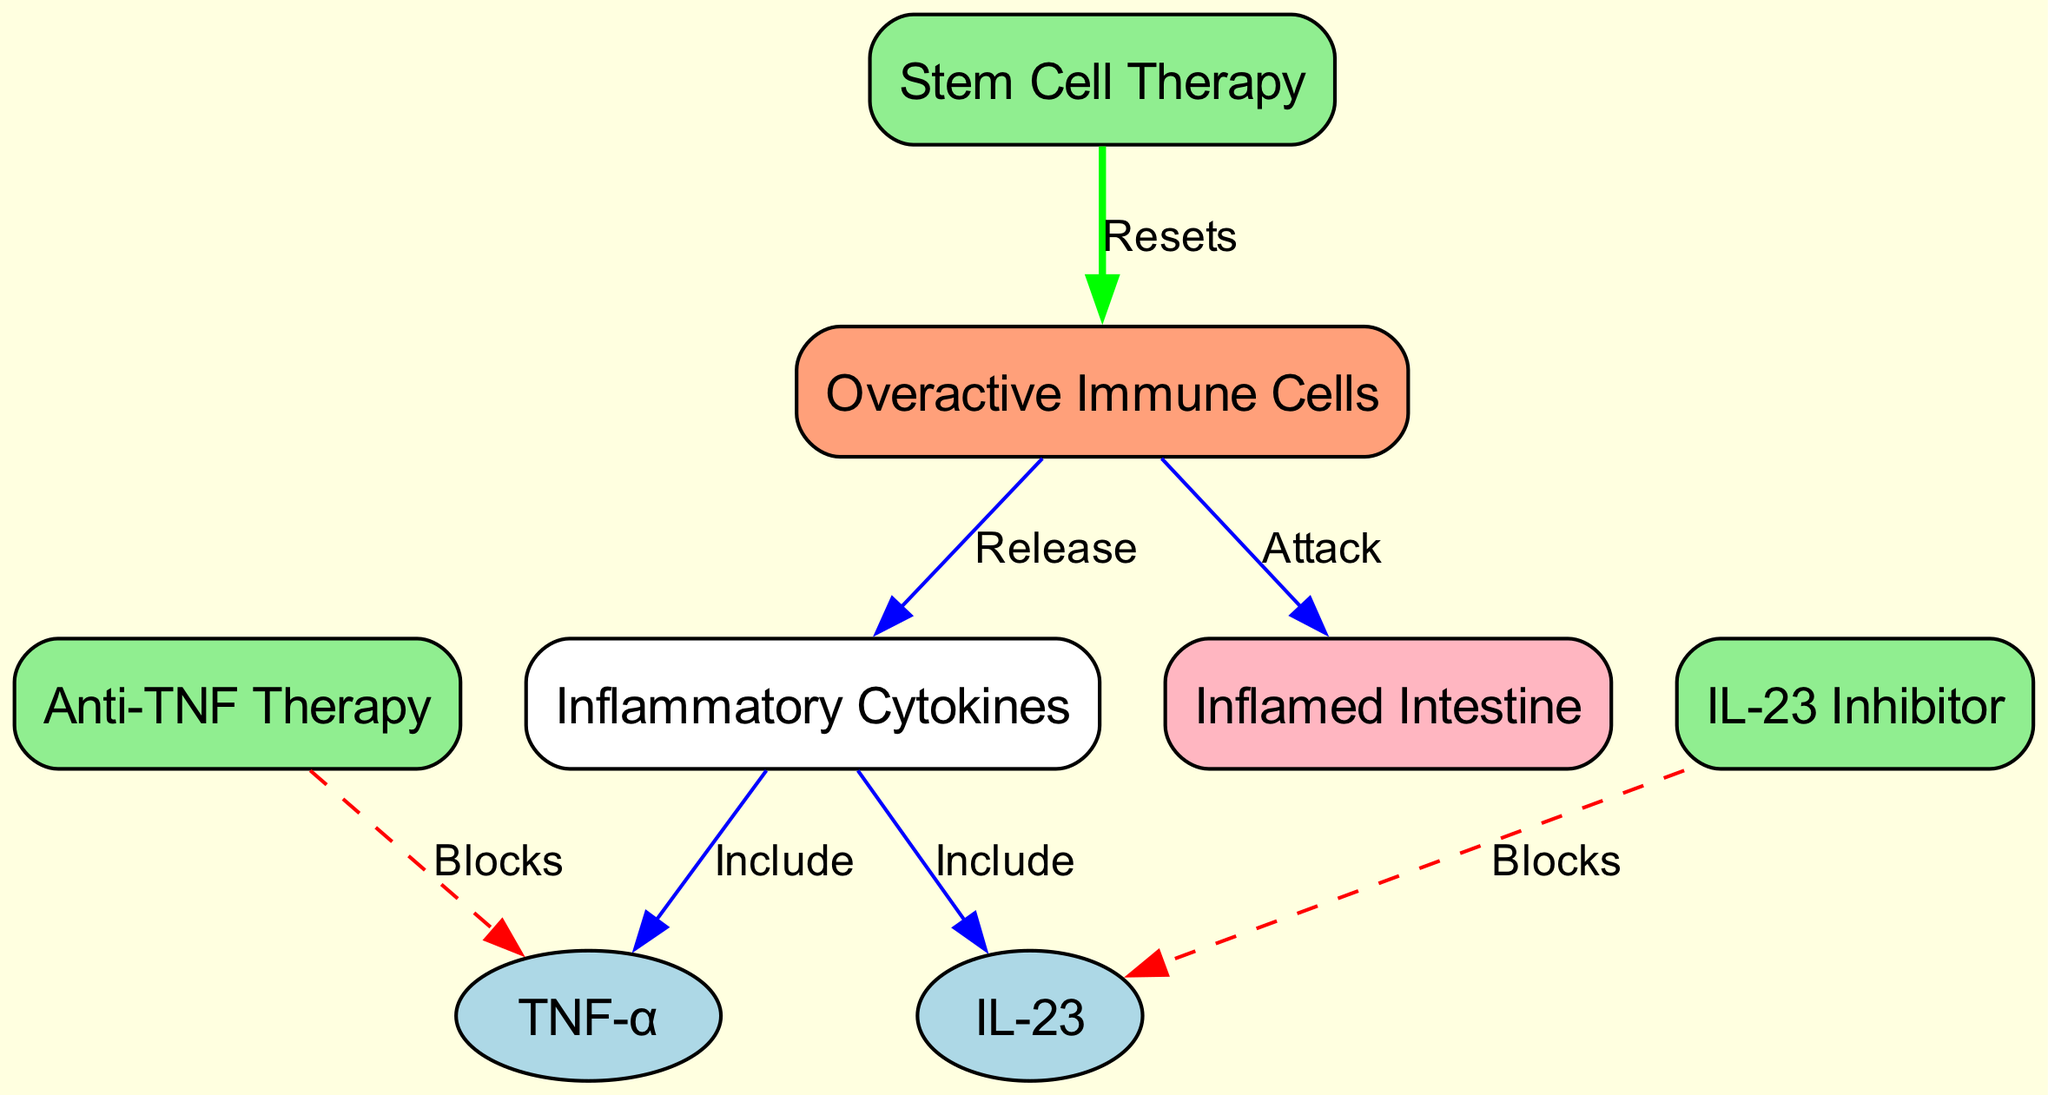What is the main target of overactive immune cells? The diagram shows that overactive immune cells 'attack' the inflamed intestine, indicating that the inflamed intestine is their main target.
Answer: inflamed intestine How many treatments are represented in the diagram? By counting the therapy nodes, there are three treatments illustrated: Anti-TNF Therapy, IL-23 Inhibitor, and Stem Cell Therapy.
Answer: 3 Which cytokine is blocked by Anti-TNF Therapy? The diagram indicates that Anti-TNF Therapy 'blocks' TNF-α, making it clear that TNF-α is the specific cytokine being targeted.
Answer: TNF-α What happens to immune cells when Stem Cell Therapy is applied? The diagram shows that Stem Cell Therapy 'resets' immune cells, suggesting that it aims to restore the function of these cells.
Answer: Resets Which two inflammatory cytokines are included in the diagram? The two inflammatory cytokines demonstrated in the diagram are TNF-α and IL-23, both of which have connections to the inflamed intestine.
Answer: TNF-α and IL-23 What color represents cytokines in the diagram? The nodes representing cytokines, TNF-α and IL-23, are colored light blue in the diagram.
Answer: light blue How do immune cells interact with cytokines according to the diagram? The diagram illustrates that overactive immune cells 'release' cytokines, indicating that these immune cells trigger the release of these inflammatory substances.
Answer: Release What is the effect of IL-23 Inhibitor on IL-23? According to the diagram, IL-23 Inhibitor 'blocks' IL-23, demonstrating that this treatment specifically targets and inhibits IL-23.
Answer: Blocks What type of diagram is being described? The diagram is a directed graph that visually represents the relationships between elements involved in the inflammatory process and potential treatments for Crohn's disease.
Answer: Directed graph 